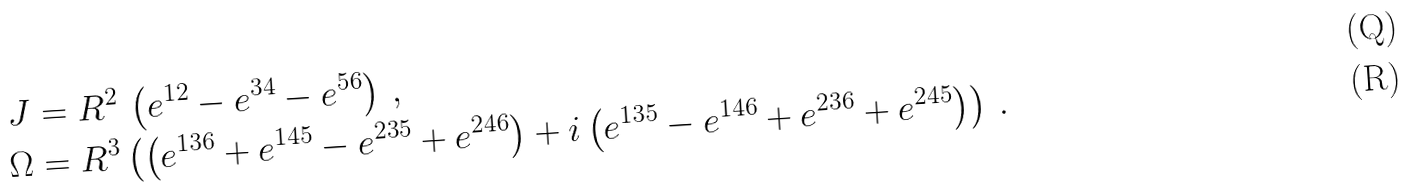Convert formula to latex. <formula><loc_0><loc_0><loc_500><loc_500>J & = R ^ { 2 } \, \left ( e ^ { 1 2 } - e ^ { 3 4 } - e ^ { 5 6 } \right ) \, , \\ \Omega & = R ^ { 3 } \left ( \left ( e ^ { 1 3 6 } + e ^ { 1 4 5 } - e ^ { 2 3 5 } + e ^ { 2 4 6 } \right ) + i \left ( e ^ { 1 3 5 } - e ^ { 1 4 6 } + e ^ { 2 3 6 } + e ^ { 2 4 5 } \right ) \right ) \, .</formula> 